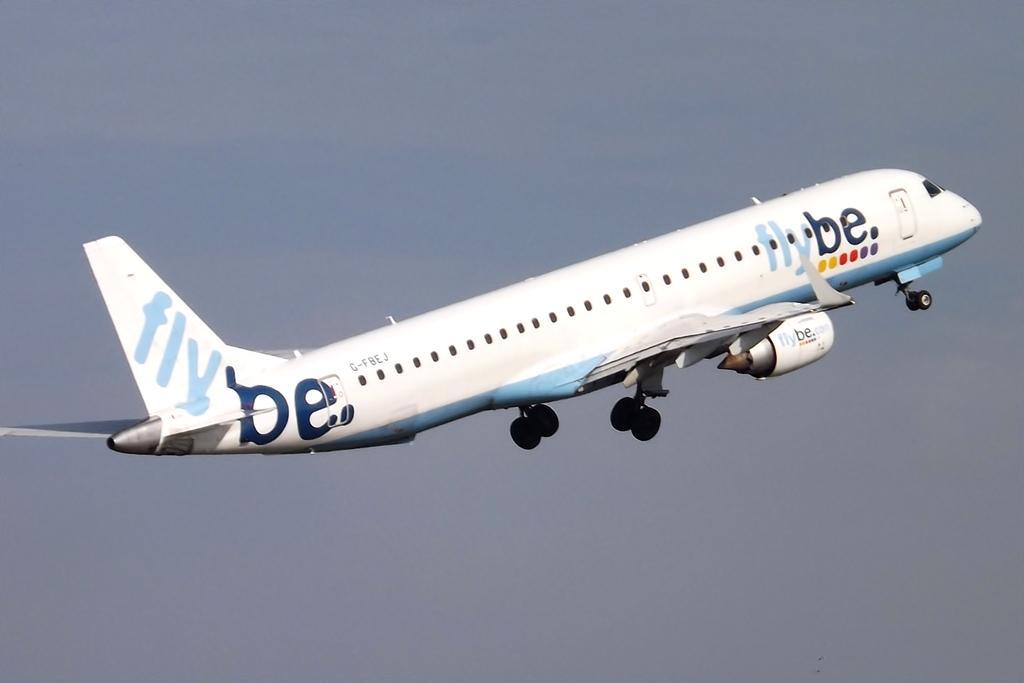Can you describe this image briefly? In the center of the image we can see an aeroplane flying in the sky. 